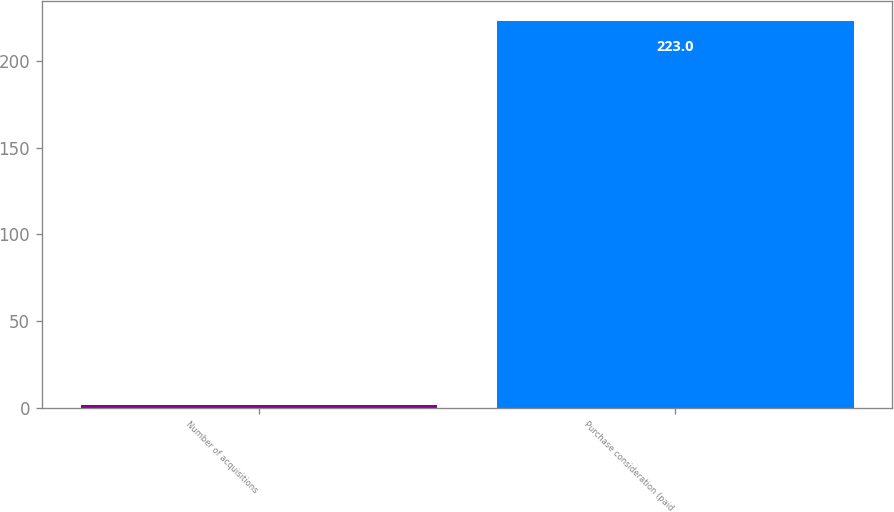<chart> <loc_0><loc_0><loc_500><loc_500><bar_chart><fcel>Number of acquisitions<fcel>Purchase consideration (paid<nl><fcel>2<fcel>223<nl></chart> 